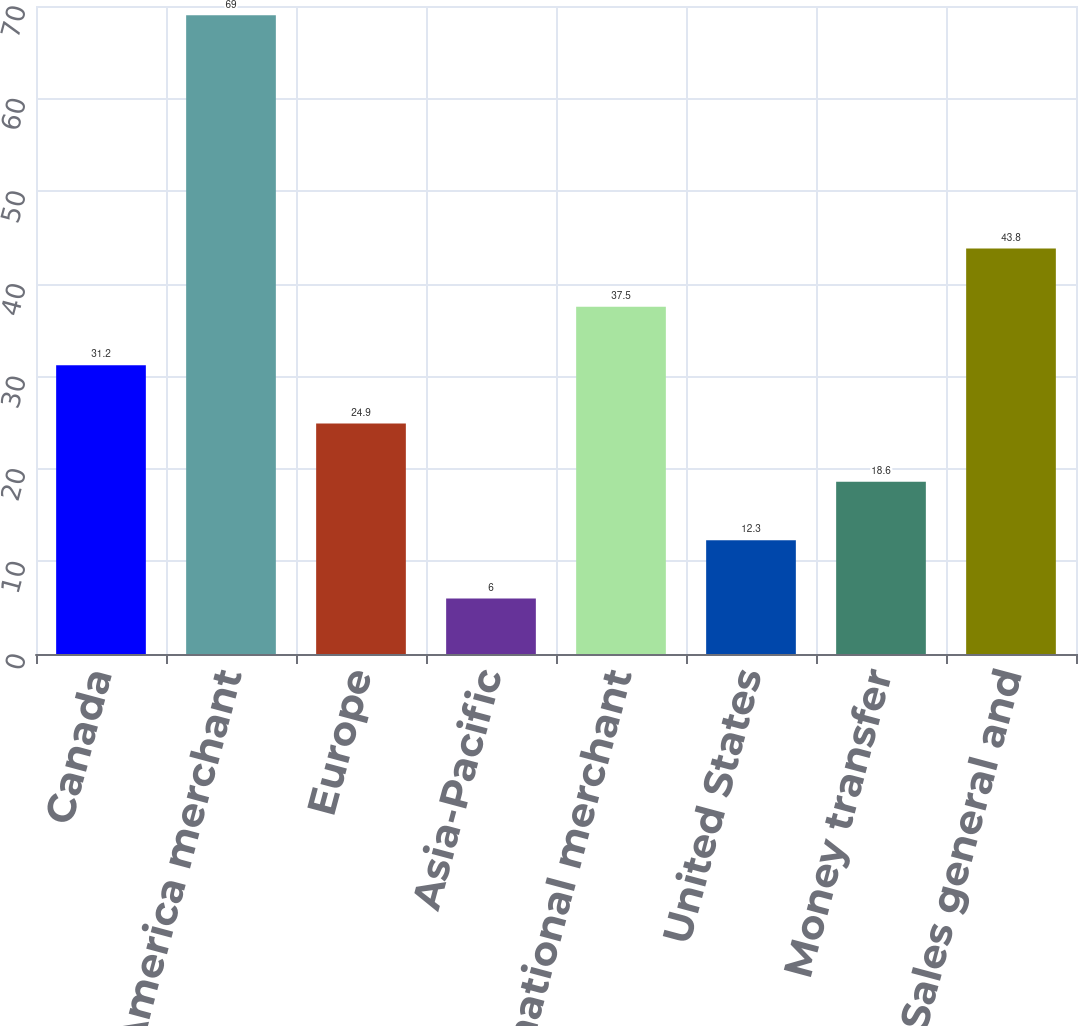Convert chart to OTSL. <chart><loc_0><loc_0><loc_500><loc_500><bar_chart><fcel>Canada<fcel>North America merchant<fcel>Europe<fcel>Asia-Pacific<fcel>International merchant<fcel>United States<fcel>Money transfer<fcel>Sales general and<nl><fcel>31.2<fcel>69<fcel>24.9<fcel>6<fcel>37.5<fcel>12.3<fcel>18.6<fcel>43.8<nl></chart> 